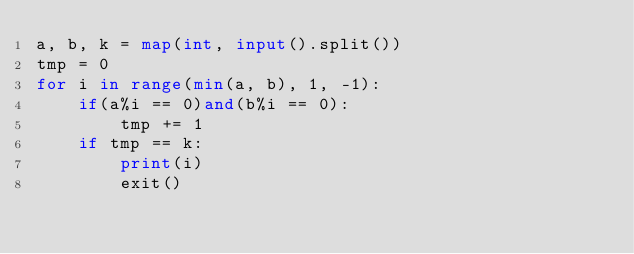<code> <loc_0><loc_0><loc_500><loc_500><_Python_>a, b, k = map(int, input().split())
tmp = 0
for i in range(min(a, b), 1, -1):
    if(a%i == 0)and(b%i == 0):
        tmp += 1
    if tmp == k:
        print(i)
        exit()</code> 